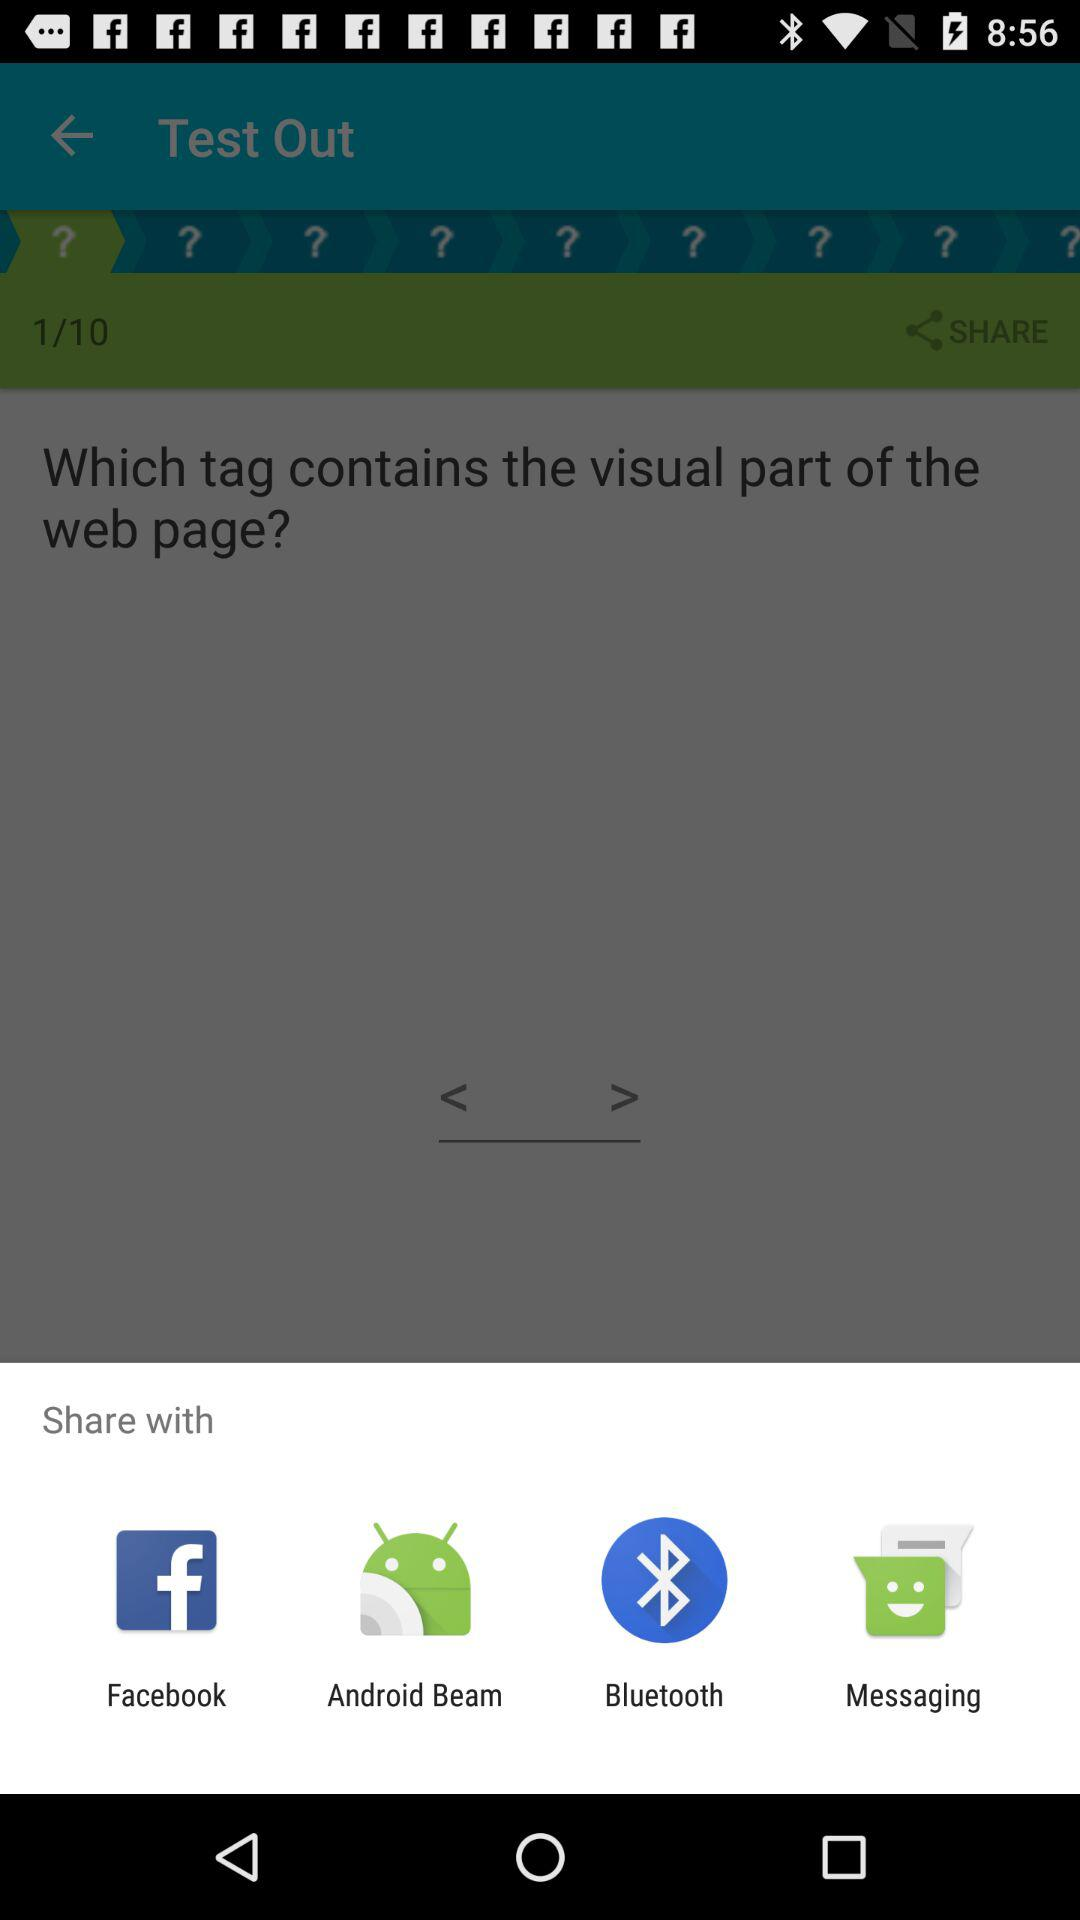Which sharing options are given? The sharing options are "Facebook", "Android Beam", "Bluetooth" and "Messaging". 